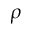Convert formula to latex. <formula><loc_0><loc_0><loc_500><loc_500>\rho</formula> 